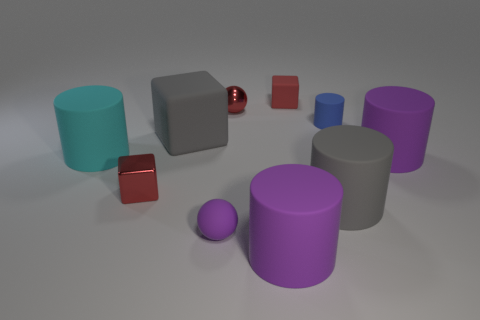Is the small shiny block the same color as the metal ball?
Keep it short and to the point. Yes. Is the number of purple spheres that are on the left side of the large gray matte cube greater than the number of small rubber cubes?
Make the answer very short. No. What shape is the red object that is made of the same material as the big cyan cylinder?
Keep it short and to the point. Cube. There is a purple rubber cylinder to the right of the gray cylinder; does it have the same size as the shiny block?
Ensure brevity in your answer.  No. There is a gray object that is behind the big thing that is left of the big gray rubber cube; what is its shape?
Your response must be concise. Cube. There is a gray thing to the left of the matte thing that is behind the small blue thing; what size is it?
Ensure brevity in your answer.  Large. What color is the tiny cube behind the large cyan matte cylinder?
Provide a succinct answer. Red. There is a blue cylinder that is the same material as the large cyan cylinder; what size is it?
Make the answer very short. Small. What number of small brown matte objects are the same shape as the small red rubber object?
Your answer should be very brief. 0. What is the material of the red ball that is the same size as the blue cylinder?
Provide a succinct answer. Metal. 